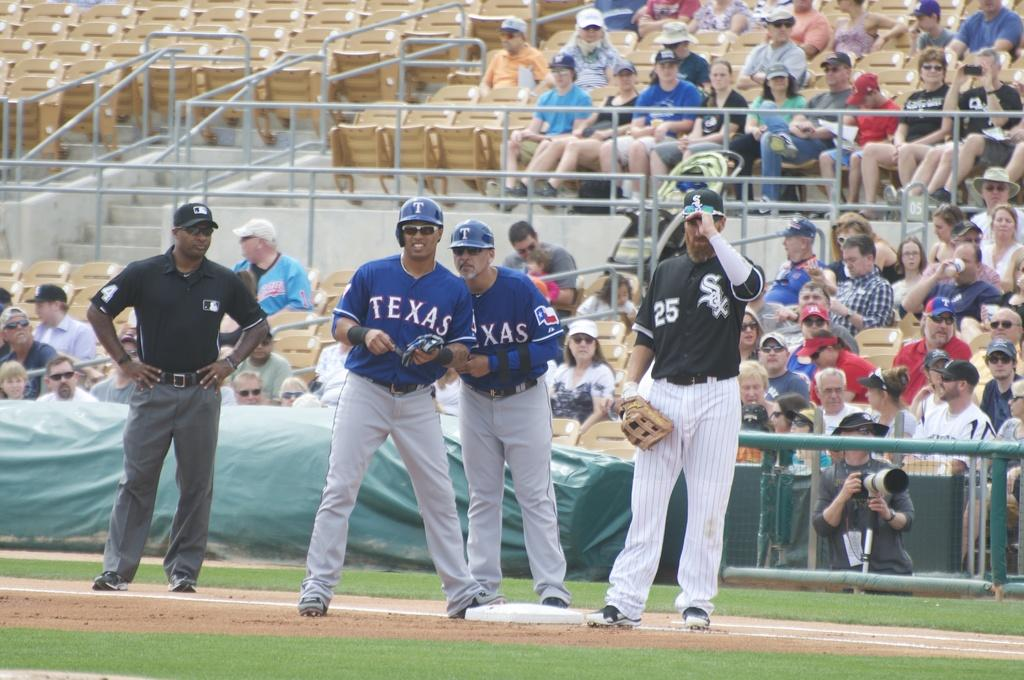<image>
Relay a brief, clear account of the picture shown. Several Texas players and a White Sox player on a baseball field. 